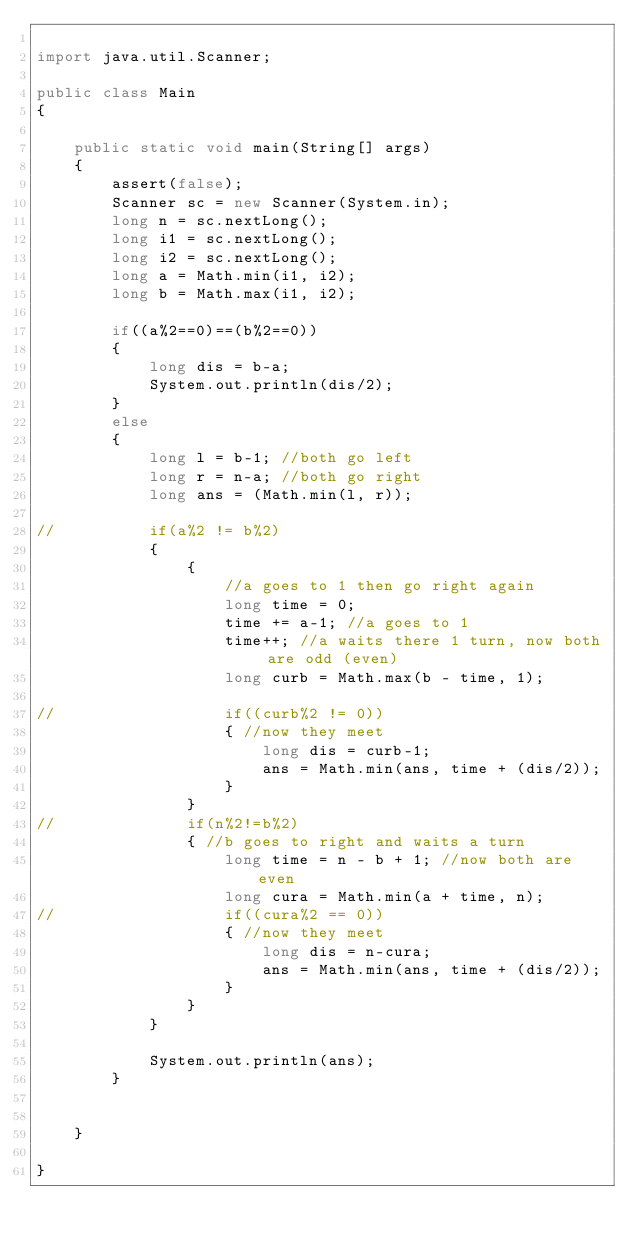Convert code to text. <code><loc_0><loc_0><loc_500><loc_500><_Java_>
import java.util.Scanner;

public class Main
{

	public static void main(String[] args) 
	{
		assert(false);
		Scanner sc = new Scanner(System.in);
		long n = sc.nextLong();
		long i1 = sc.nextLong();
		long i2 = sc.nextLong();
		long a = Math.min(i1, i2);
		long b = Math.max(i1, i2);
		
		if((a%2==0)==(b%2==0))
		{
			long dis = b-a;
			System.out.println(dis/2);
		}
		else
		{
			long l = b-1; //both go left
			long r = n-a; //both go right
			long ans = (Math.min(l, r));
			
//			if(a%2 != b%2)
			{
				{
					//a goes to 1 then go right again
					long time = 0;
					time += a-1; //a goes to 1
					time++; //a waits there 1 turn, now both are odd (even)
					long curb = Math.max(b - time, 1);
					
//					if((curb%2 != 0))
					{ //now they meet
						long dis = curb-1;
						ans = Math.min(ans, time + (dis/2));
					}
				}
//				if(n%2!=b%2)
				{ //b goes to right and waits a turn
					long time = n - b + 1; //now both are even
					long cura = Math.min(a + time, n);
//					if((cura%2 == 0))
					{ //now they meet
						long dis = n-cura;
						ans = Math.min(ans, time + (dis/2));
					}
				}
			}
			
			System.out.println(ans);
		}
			

	}

}
</code> 